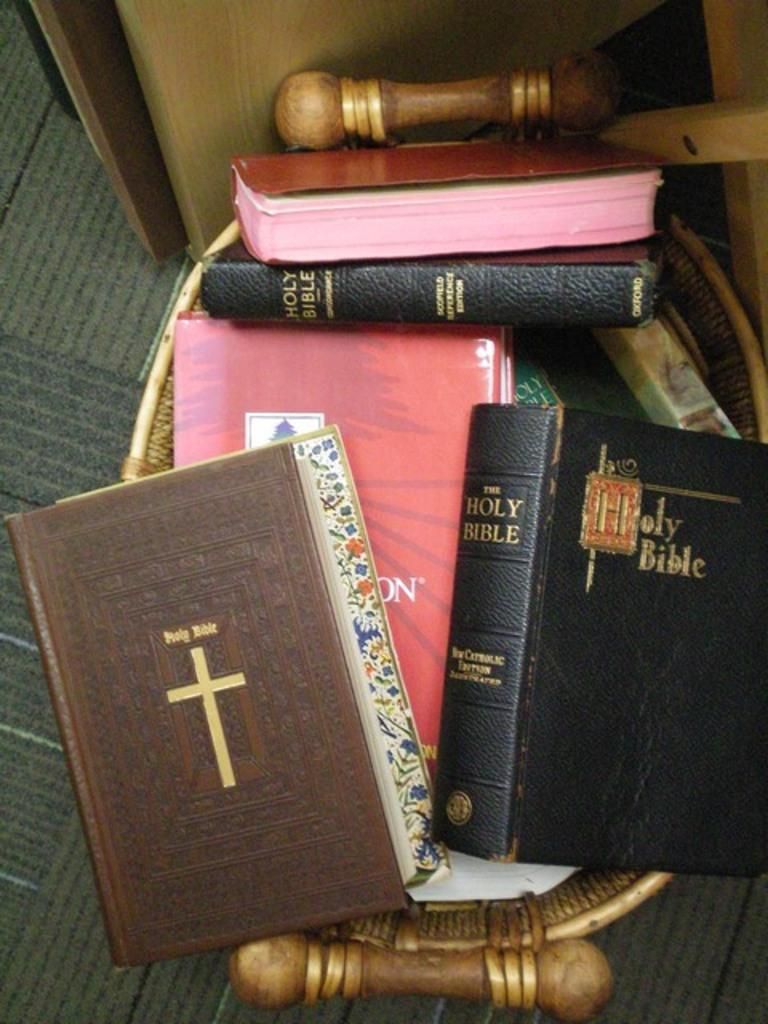<image>
Provide a brief description of the given image. A stack of different versions of The Holy Bible sitting on a stool. 